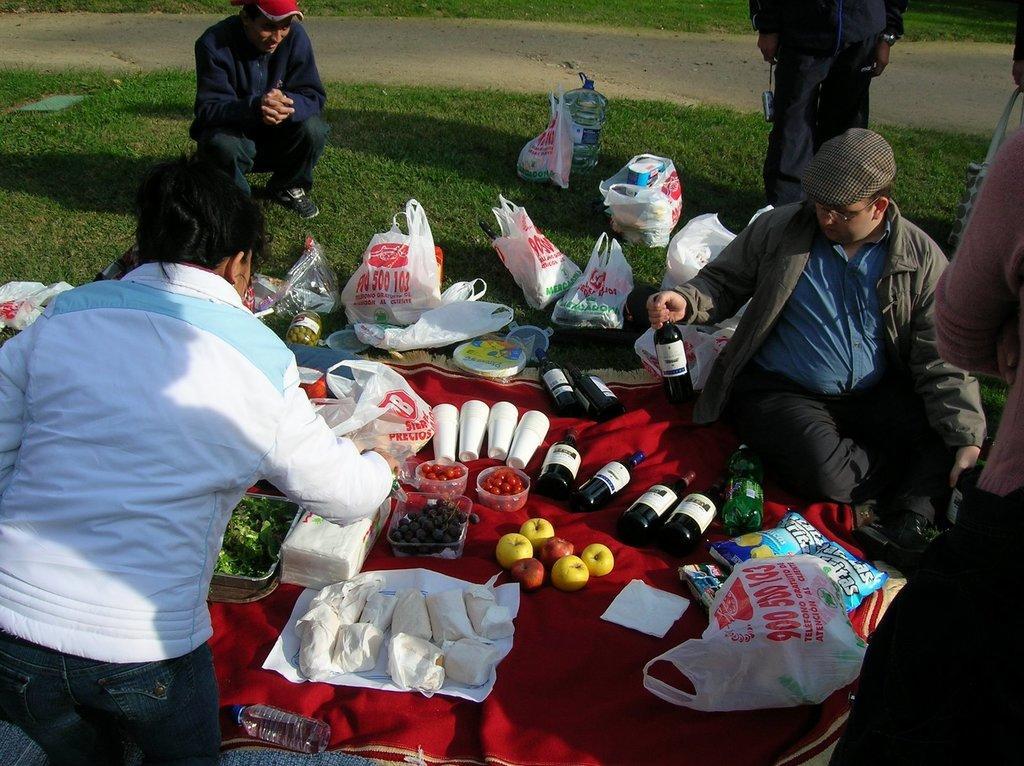Can you describe this image briefly? In the center of the image we can see a cloth. On cloth we can see the bottles, glasses, fruits, bowls which contains fruits, vegetables, food packets, covers. Beside that we can see some persons are sitting. In the background of the image we can see the ground, some persons are standing, road, grass. 